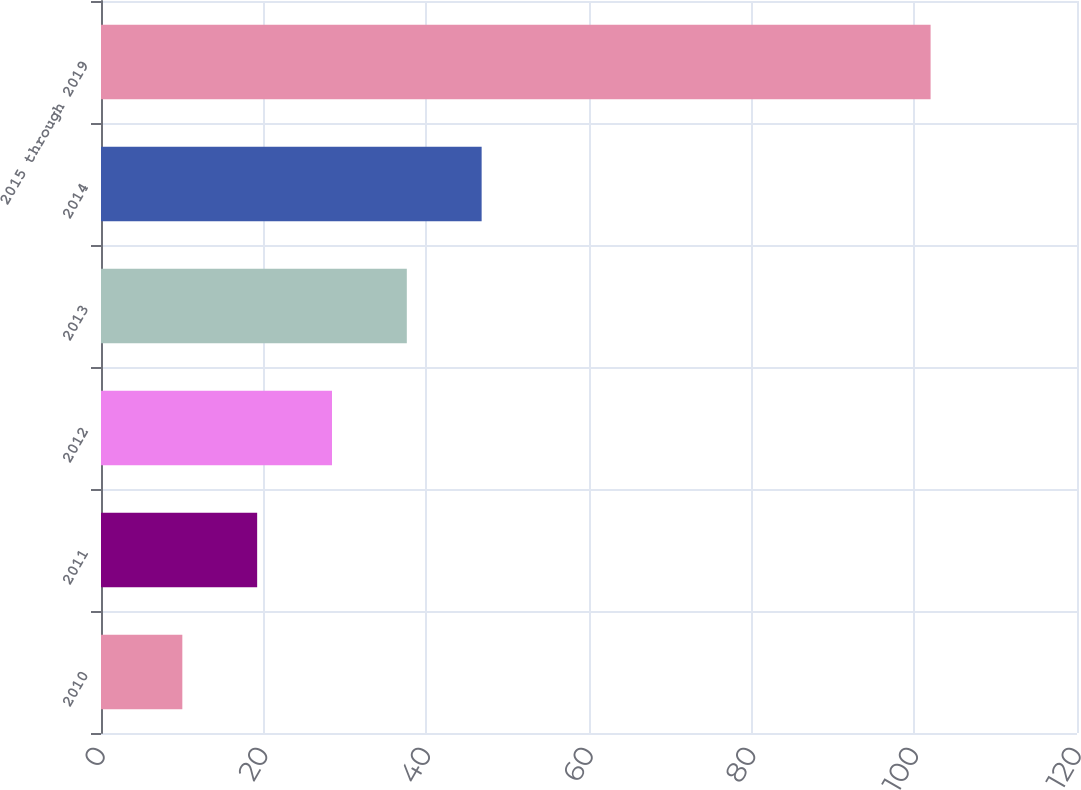<chart> <loc_0><loc_0><loc_500><loc_500><bar_chart><fcel>2010<fcel>2011<fcel>2012<fcel>2013<fcel>2014<fcel>2015 through 2019<nl><fcel>10<fcel>19.2<fcel>28.4<fcel>37.6<fcel>46.8<fcel>102<nl></chart> 